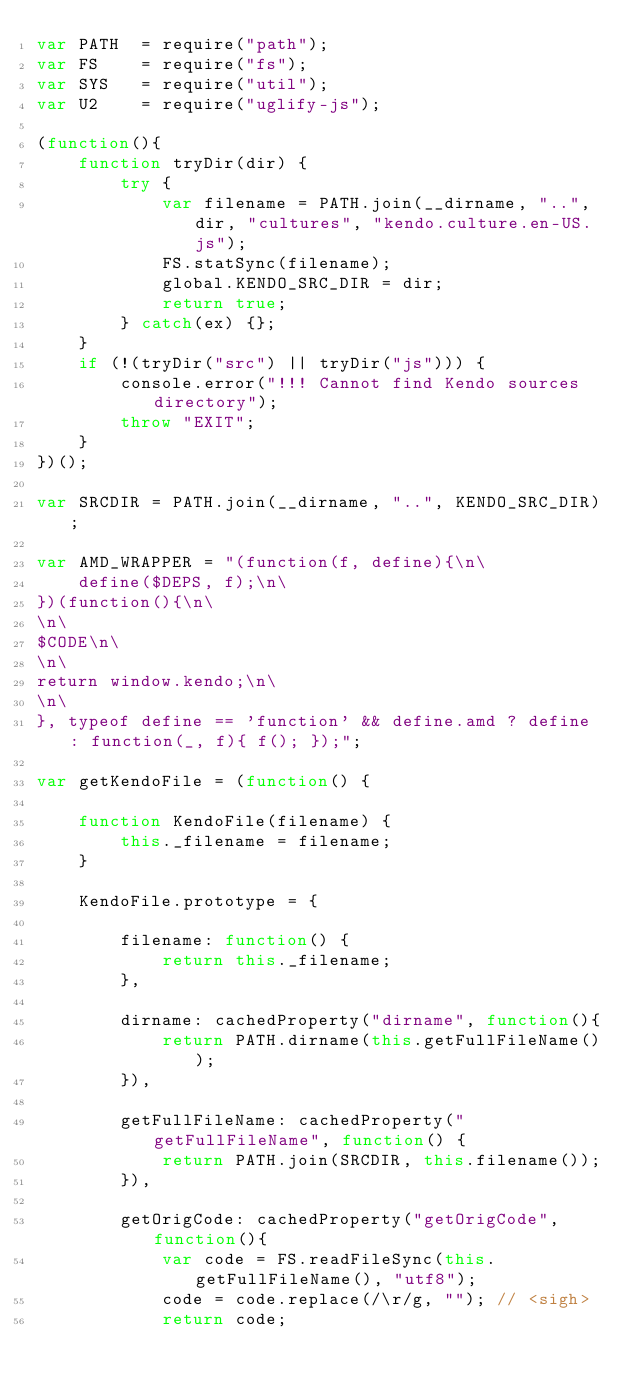<code> <loc_0><loc_0><loc_500><loc_500><_JavaScript_>var PATH  = require("path");
var FS    = require("fs");
var SYS   = require("util");
var U2    = require("uglify-js");

(function(){
    function tryDir(dir) {
        try {
            var filename = PATH.join(__dirname, "..", dir, "cultures", "kendo.culture.en-US.js");
            FS.statSync(filename);
            global.KENDO_SRC_DIR = dir;
            return true;
        } catch(ex) {};
    }
    if (!(tryDir("src") || tryDir("js"))) {
        console.error("!!! Cannot find Kendo sources directory");
        throw "EXIT";
    }
})();

var SRCDIR = PATH.join(__dirname, "..", KENDO_SRC_DIR);

var AMD_WRAPPER = "(function(f, define){\n\
    define($DEPS, f);\n\
})(function(){\n\
\n\
$CODE\n\
\n\
return window.kendo;\n\
\n\
}, typeof define == 'function' && define.amd ? define : function(_, f){ f(); });";

var getKendoFile = (function() {

    function KendoFile(filename) {
        this._filename = filename;
    }

    KendoFile.prototype = {

        filename: function() {
            return this._filename;
        },

        dirname: cachedProperty("dirname", function(){
            return PATH.dirname(this.getFullFileName());
        }),

        getFullFileName: cachedProperty("getFullFileName", function() {
            return PATH.join(SRCDIR, this.filename());
        }),

        getOrigCode: cachedProperty("getOrigCode", function(){
            var code = FS.readFileSync(this.getFullFileName(), "utf8");
            code = code.replace(/\r/g, ""); // <sigh>
            return code;</code> 